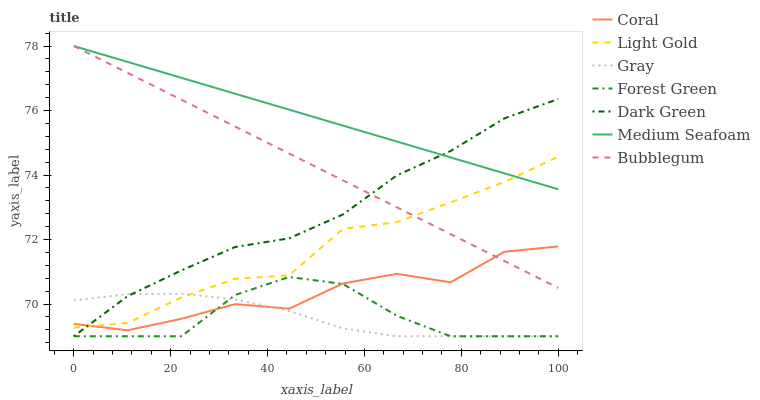Does Gray have the minimum area under the curve?
Answer yes or no. Yes. Does Medium Seafoam have the maximum area under the curve?
Answer yes or no. Yes. Does Coral have the minimum area under the curve?
Answer yes or no. No. Does Coral have the maximum area under the curve?
Answer yes or no. No. Is Bubblegum the smoothest?
Answer yes or no. Yes. Is Coral the roughest?
Answer yes or no. Yes. Is Coral the smoothest?
Answer yes or no. No. Is Bubblegum the roughest?
Answer yes or no. No. Does Gray have the lowest value?
Answer yes or no. Yes. Does Coral have the lowest value?
Answer yes or no. No. Does Medium Seafoam have the highest value?
Answer yes or no. Yes. Does Coral have the highest value?
Answer yes or no. No. Is Forest Green less than Bubblegum?
Answer yes or no. Yes. Is Bubblegum greater than Gray?
Answer yes or no. Yes. Does Forest Green intersect Dark Green?
Answer yes or no. Yes. Is Forest Green less than Dark Green?
Answer yes or no. No. Is Forest Green greater than Dark Green?
Answer yes or no. No. Does Forest Green intersect Bubblegum?
Answer yes or no. No. 